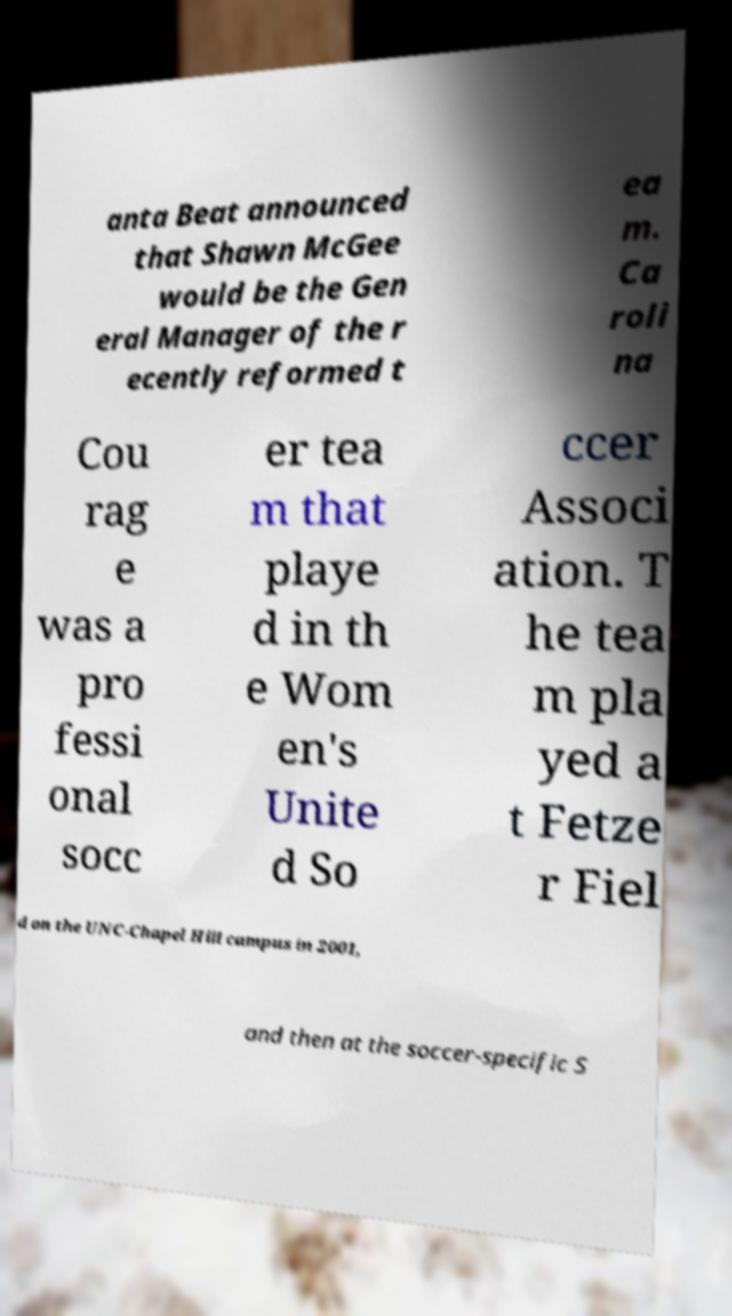There's text embedded in this image that I need extracted. Can you transcribe it verbatim? anta Beat announced that Shawn McGee would be the Gen eral Manager of the r ecently reformed t ea m. Ca roli na Cou rag e was a pro fessi onal socc er tea m that playe d in th e Wom en's Unite d So ccer Associ ation. T he tea m pla yed a t Fetze r Fiel d on the UNC-Chapel Hill campus in 2001, and then at the soccer-specific S 